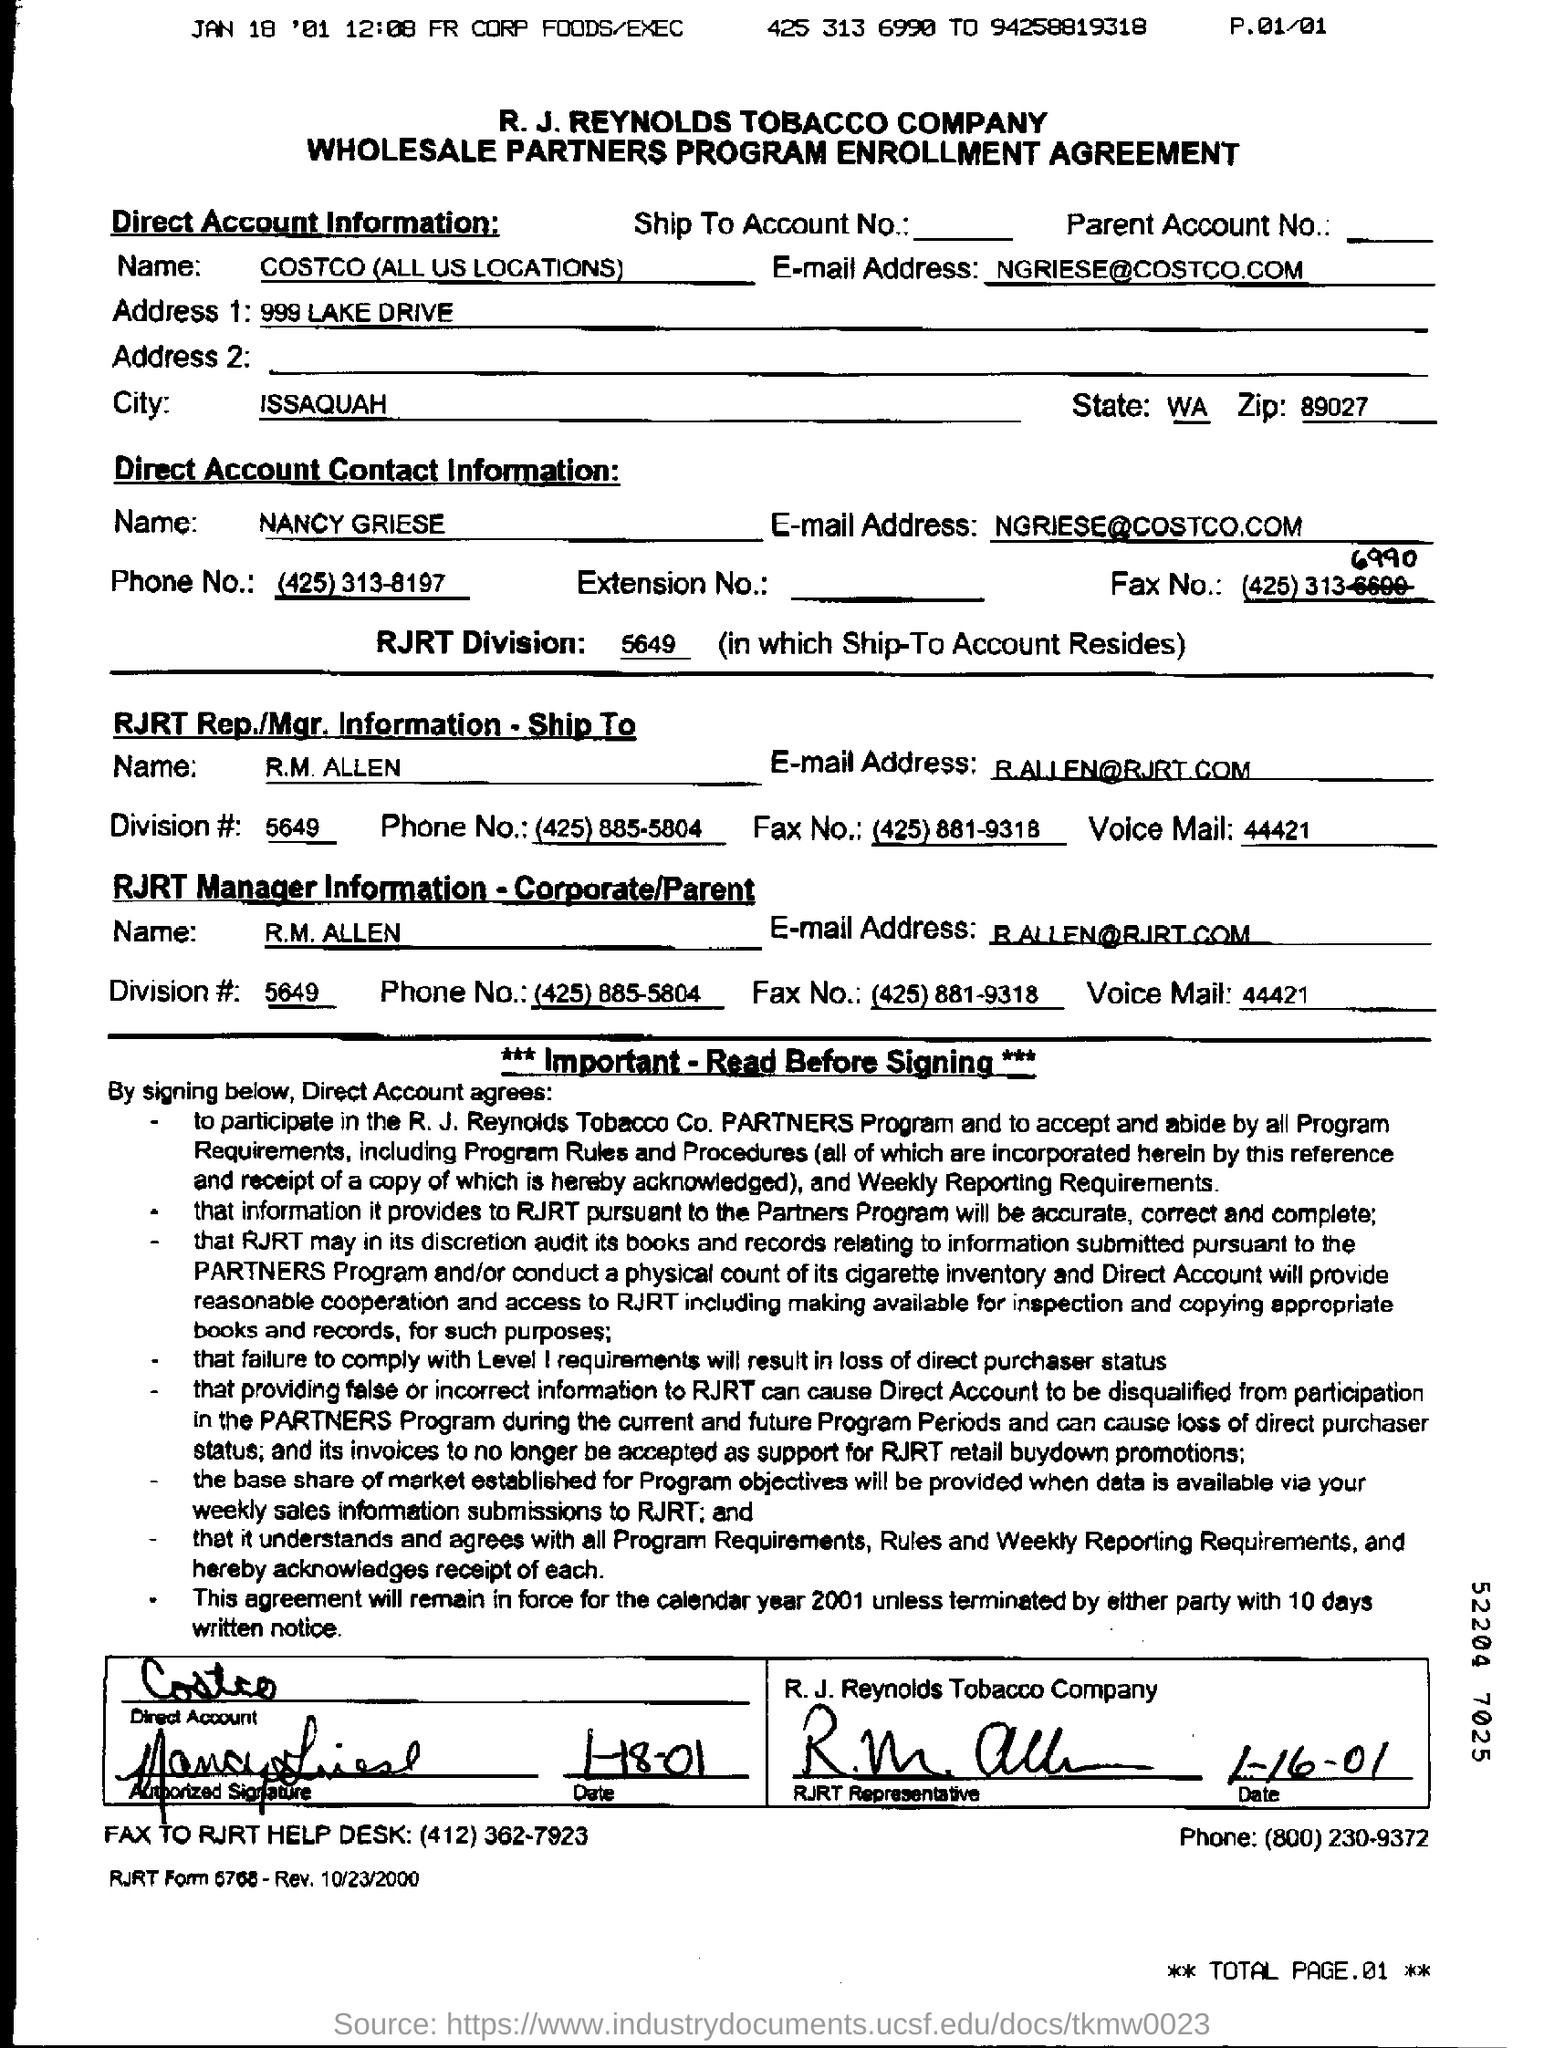Outline some significant characteristics in this image. The document mentions a company by name and provides the contact information for the account information of that company. 